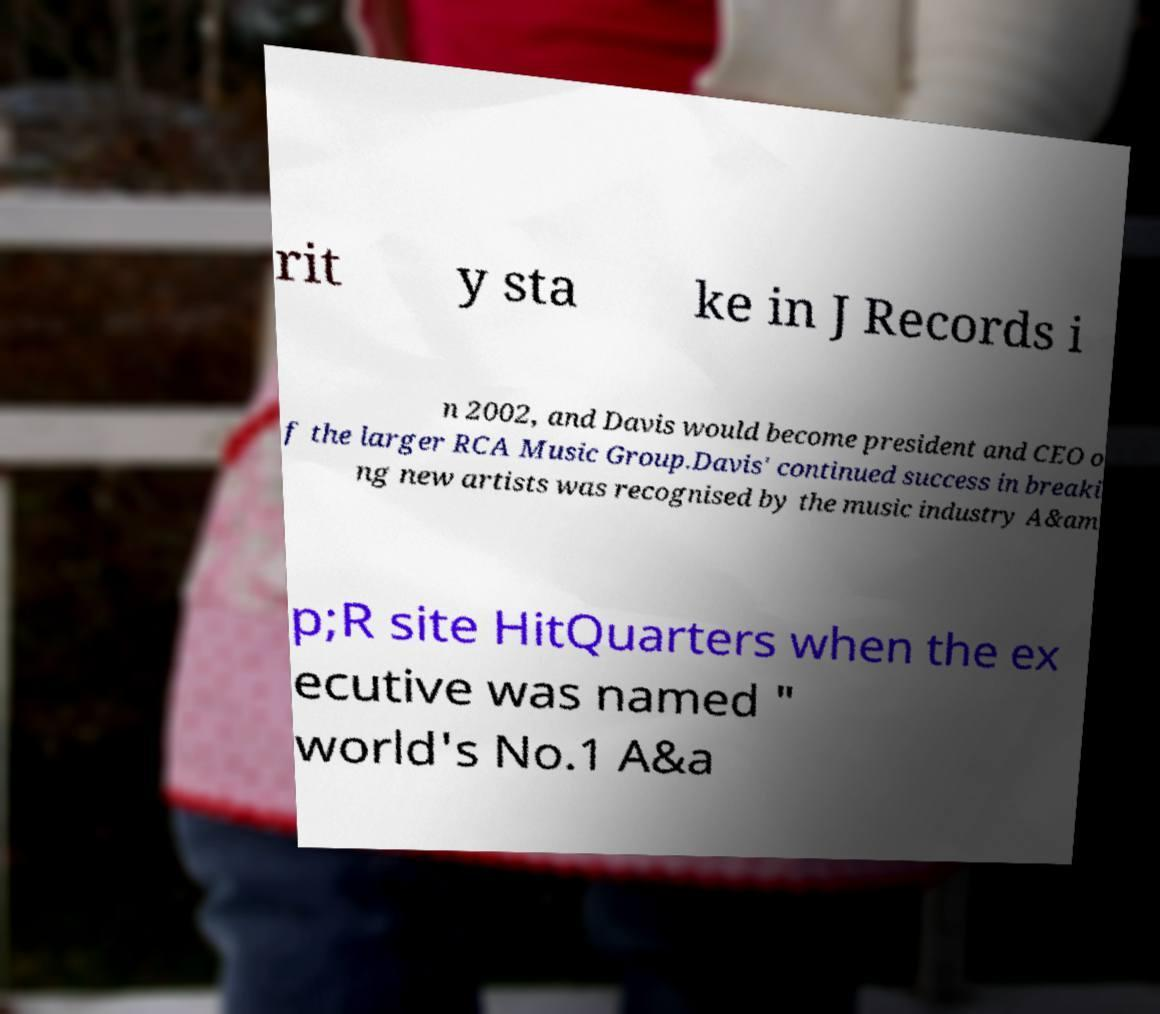What messages or text are displayed in this image? I need them in a readable, typed format. rit y sta ke in J Records i n 2002, and Davis would become president and CEO o f the larger RCA Music Group.Davis' continued success in breaki ng new artists was recognised by the music industry A&am p;R site HitQuarters when the ex ecutive was named " world's No.1 A&a 